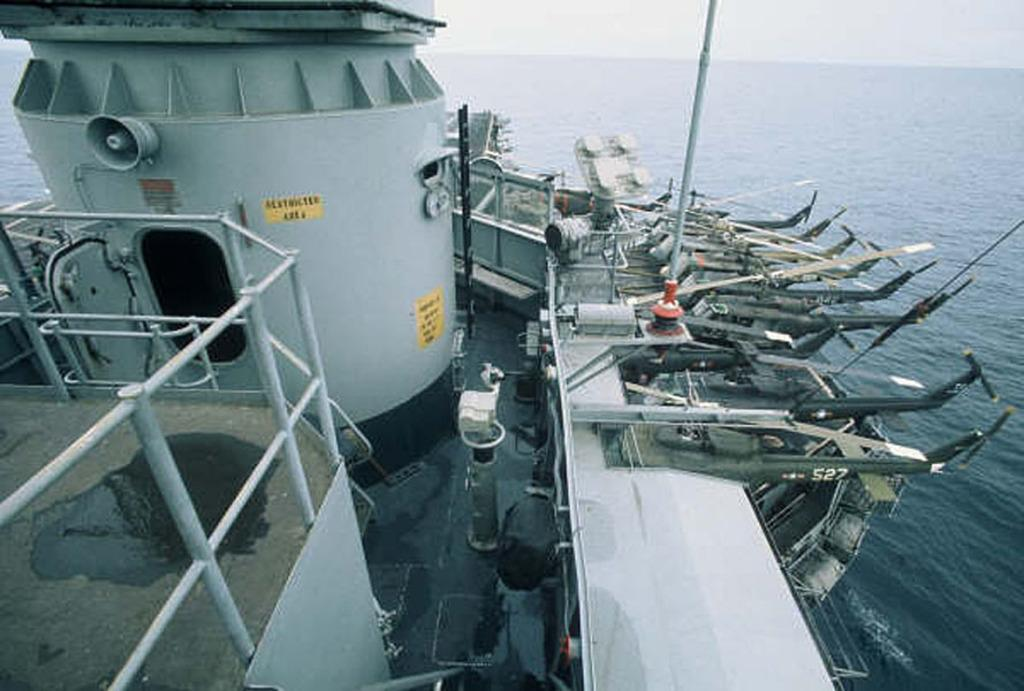What is the main subject of the image? There is a ship in the image. Where is the ship located? The ship is on the water. What can be seen in the background of the image? The sky is visible in the background of the image. How many spiders are crawling on the ship in the image? There are no spiders visible in the image; it features a ship on the water with the sky in the background. What effect does the presence of friends have on the ship in the image? There is no mention of friends in the image, so it is impossible to determine any effect they might have. 